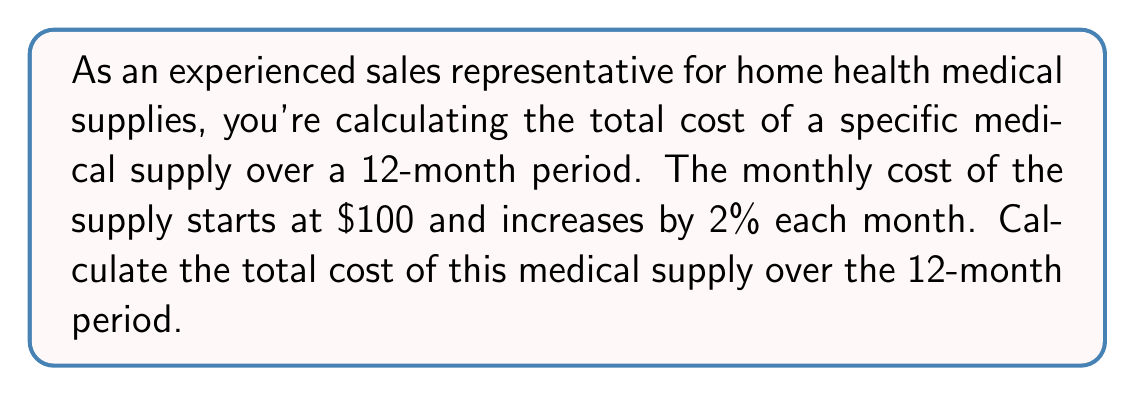Teach me how to tackle this problem. To solve this problem, we need to recognize that this is a geometric sequence with a common ratio of 1.02 (2% increase each month).

Let's break it down step-by-step:

1) The first term, $a_1 = 100$

2) The common ratio, $r = 1.02$ (100% + 2% = 102% = 1.02)

3) We need to find the sum of 12 terms in this geometric sequence.

4) The formula for the sum of a geometric sequence is:

   $$S_n = \frac{a_1(1-r^n)}{1-r}$$

   Where $S_n$ is the sum of $n$ terms, $a_1$ is the first term, $r$ is the common ratio, and $n$ is the number of terms.

5) Substituting our values:

   $$S_{12} = \frac{100(1-1.02^{12})}{1-1.02}$$

6) Calculate $1.02^{12}$:
   
   $$1.02^{12} \approx 1.2682$$

7) Now we can solve:

   $$S_{12} = \frac{100(1-1.2682)}{1-1.02} = \frac{100(-0.2682)}{-0.02} \approx 1341.02$$

Therefore, the total cost over the 12-month period is approximately $1,341.02.
Answer: $1,341.02 